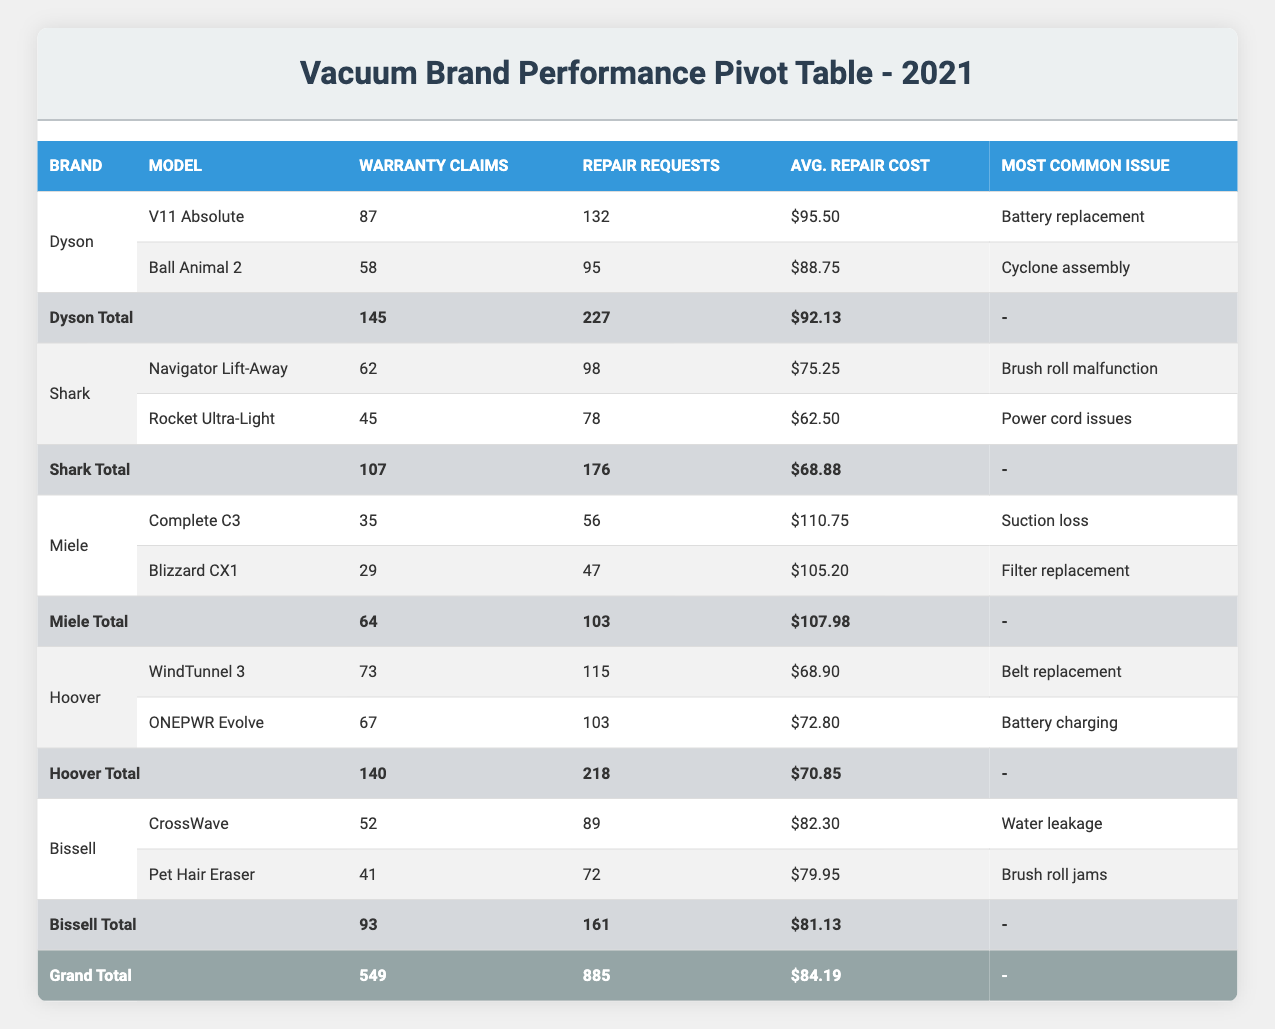What is the total number of warranty claims for all brands? To find the total warranty claims, add the warranty claims from each brand: 87 (Dyson) + 62 (Shark) + 35 (Miele) + 73 (Hoover) + 52 (Bissell) + 58 (Dyson) + 45 (Shark) + 29 (Miele) + 67 (Hoover) + 41 (Bissell) = 549.
Answer: 549 Which brand has the highest average repair cost? Looking at the average repair costs, Miele's Complete C3 has $110.75 and Blizzard CX1 has $105.20. Dyson's V11 Absolute has $95.50 and Ball Animal 2 has $88.75. Shark's models range from $62.50 to $75.25, Hoover's from $68.90 to $72.80, and Bissell's from $79.95 to $82.30. Miele's average repair cost of $107.98 is the highest.
Answer: Miele How many repair service requests did Hoover receive in total? To calculate Hoover's total repair service requests, sum them up: WindTunnel 3 had 115 and ONEPWR Evolve had 103. So, 115 + 103 = 218.
Answer: 218 Is it true that Bissell has more warranty claims than Miele? Bissell's total warranty claims are 52 (CrossWave) + 41 (Pet Hair Eraser) = 93. Miele's total is 35 (Complete C3) + 29 (Blizzard CX1) = 64. Since 93 is greater than 64, this statement is true.
Answer: Yes What is the average warranty claims per model for Shark? Shark has 2 models. Their warranty claims are 62 (Navigator Lift-Away) and 45 (Rocket Ultra-Light), totaling 107. So, the average is 107 / 2 = 53.5.
Answer: 53.5 Which model had the lowest average repair cost? Comparing the average repair costs, Shark's Rocket Ultra-Light has $62.50, which is lower than all other models. Therefore, it had the lowest average repair cost.
Answer: Rocket Ultra-Light What is the most common issue reported for Bissell vacuums? From the table, Bissell's reported most common issues are water leakage (CrossWave) and brush roll jams (Pet Hair Eraser). Therefore, two issues are associated with Bissell vacuums.
Answer: Water leakage and brush roll jams How many more warranty claims did Dyson's models have compared to Hoover's models? Dyson had 145 total warranty claims, and Hoover had 140. The difference is 145 - 140 = 5.
Answer: 5 Which brand had the highest total repair service requests? The totals are: Dyson (227), Shark (176), Miele (103), Hoover (218), Bissell (161). Dyson has the highest service requests at 227.
Answer: Dyson 